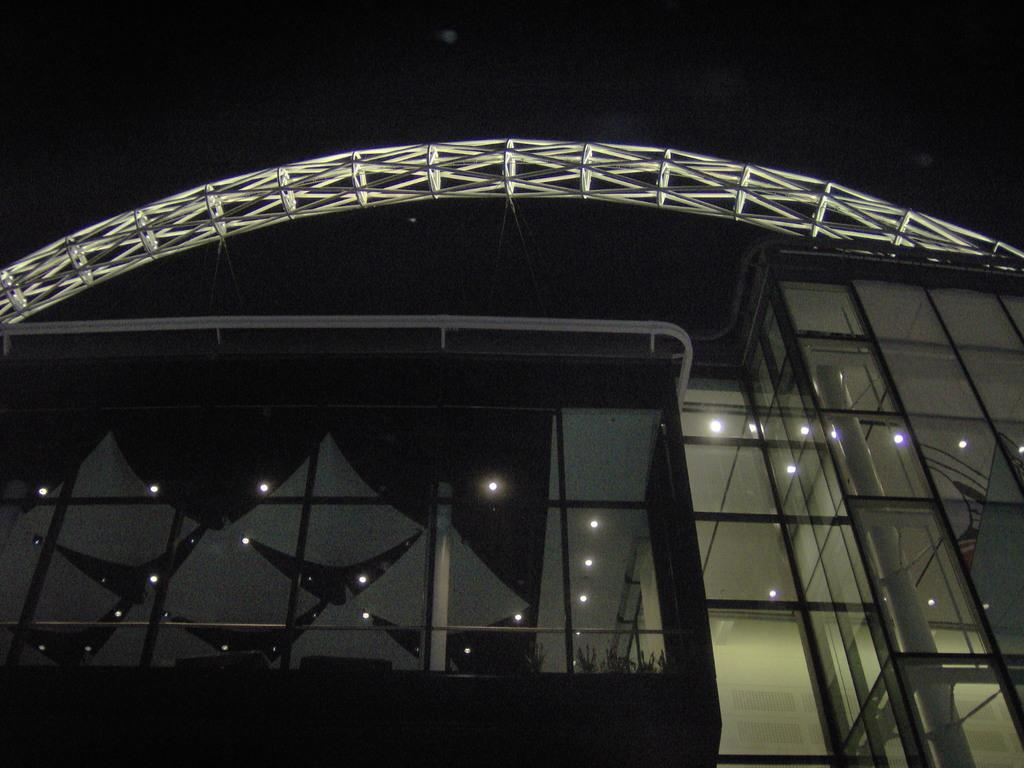What type of structure is present in the image? There is a building in the image. What feature can be seen on the building? The building has glasses. Can you describe the top of the building? There is a stand at the top of the building. What is the color of the sky in the image? The sky is black in color. Where is the grandmother sitting with her plant in the image? There is no grandmother or plant present in the image. 